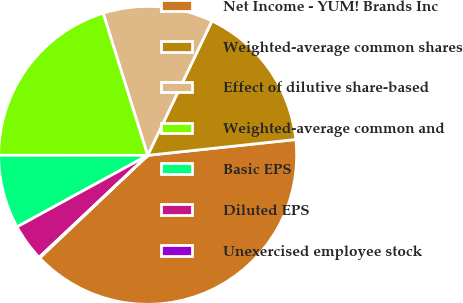Convert chart. <chart><loc_0><loc_0><loc_500><loc_500><pie_chart><fcel>Net Income - YUM! Brands Inc<fcel>Weighted-average common shares<fcel>Effect of dilutive share-based<fcel>Weighted-average common and<fcel>Basic EPS<fcel>Diluted EPS<fcel>Unexercised employee stock<nl><fcel>39.61%<fcel>16.21%<fcel>11.93%<fcel>20.16%<fcel>7.98%<fcel>4.03%<fcel>0.08%<nl></chart> 